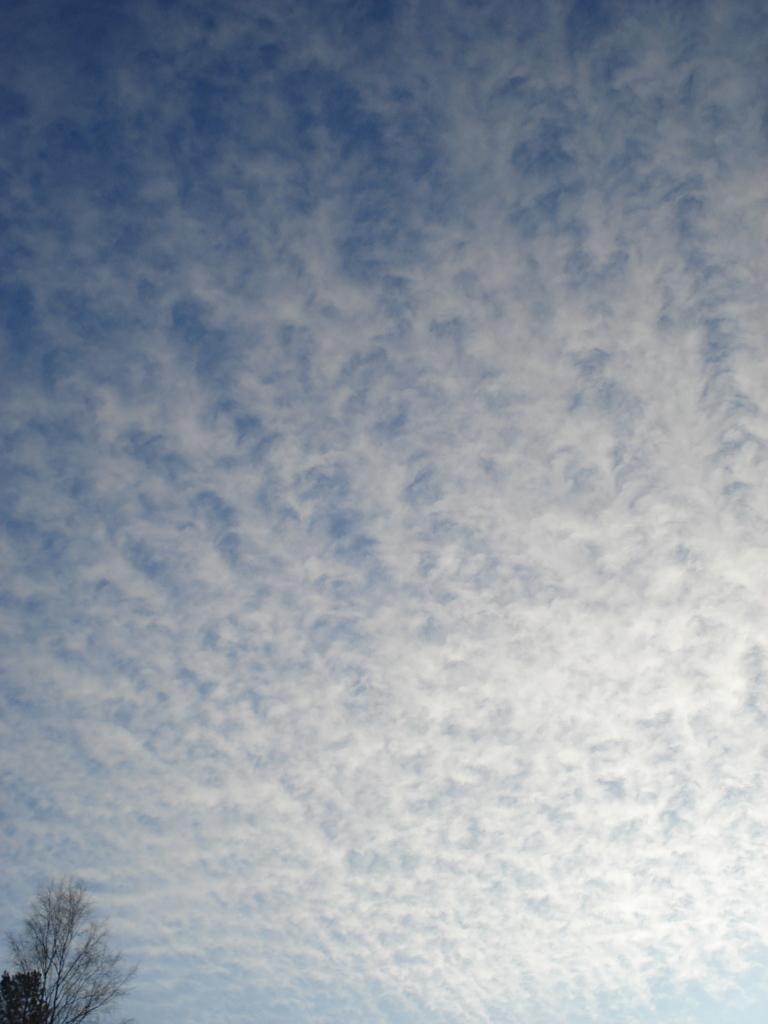Where was the picture taken? The picture was clicked outside. What can be seen in the left corner of the image? There are trees in the left corner of the image. What is visible in the background of the image? The sky is visible in the background of the image. How would you describe the sky in the image? The sky is full of clouds. What type of collar is the mother wearing in the image? There is no mother or collar present in the image. 